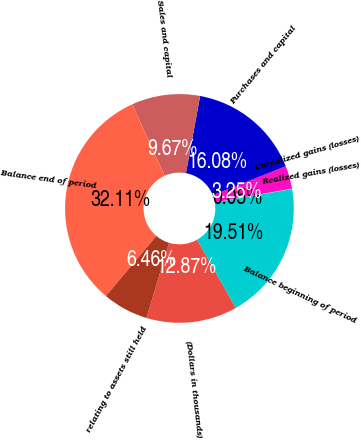Convert chart. <chart><loc_0><loc_0><loc_500><loc_500><pie_chart><fcel>(Dollars in thousands)<fcel>Balance beginning of period<fcel>Realized gains (losses)<fcel>Unrealized gains (losses)<fcel>Purchases and capital<fcel>Sales and capital<fcel>Balance end of period<fcel>relating to assets still held<nl><fcel>12.87%<fcel>19.51%<fcel>0.05%<fcel>3.25%<fcel>16.08%<fcel>9.67%<fcel>32.11%<fcel>6.46%<nl></chart> 